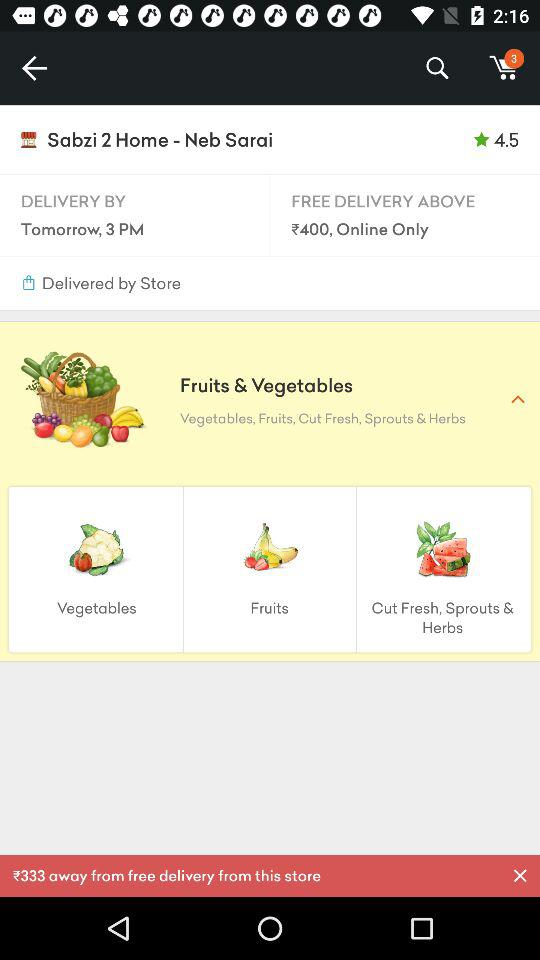What is the expected delivery time? The expected delivery time is tomorrow at 3 PM. 